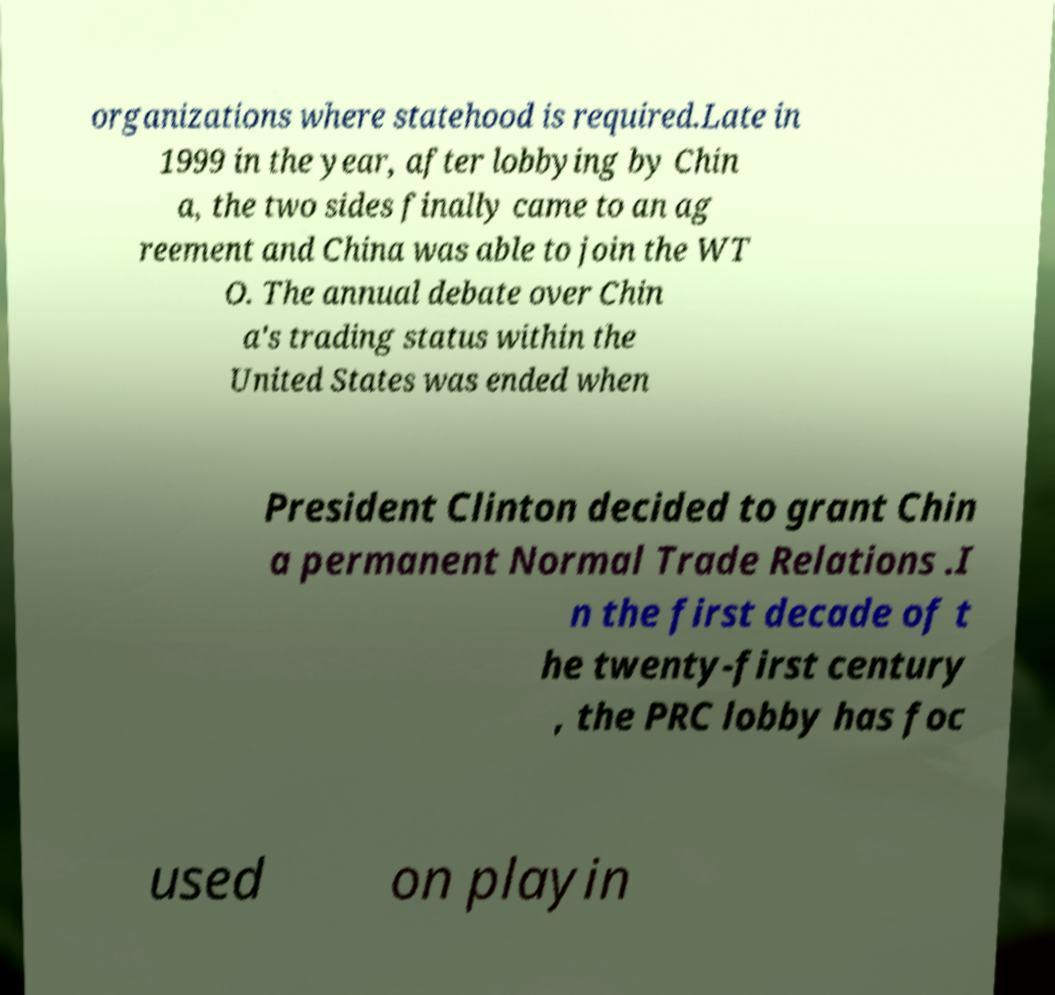Please read and relay the text visible in this image. What does it say? organizations where statehood is required.Late in 1999 in the year, after lobbying by Chin a, the two sides finally came to an ag reement and China was able to join the WT O. The annual debate over Chin a's trading status within the United States was ended when President Clinton decided to grant Chin a permanent Normal Trade Relations .I n the first decade of t he twenty-first century , the PRC lobby has foc used on playin 